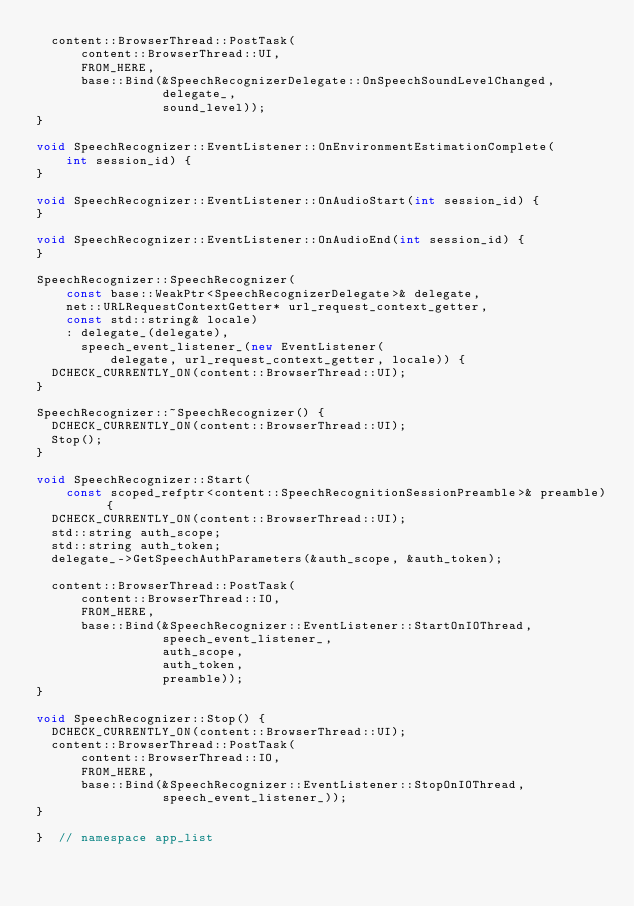Convert code to text. <code><loc_0><loc_0><loc_500><loc_500><_C++_>  content::BrowserThread::PostTask(
      content::BrowserThread::UI,
      FROM_HERE,
      base::Bind(&SpeechRecognizerDelegate::OnSpeechSoundLevelChanged,
                 delegate_,
                 sound_level));
}

void SpeechRecognizer::EventListener::OnEnvironmentEstimationComplete(
    int session_id) {
}

void SpeechRecognizer::EventListener::OnAudioStart(int session_id) {
}

void SpeechRecognizer::EventListener::OnAudioEnd(int session_id) {
}

SpeechRecognizer::SpeechRecognizer(
    const base::WeakPtr<SpeechRecognizerDelegate>& delegate,
    net::URLRequestContextGetter* url_request_context_getter,
    const std::string& locale)
    : delegate_(delegate),
      speech_event_listener_(new EventListener(
          delegate, url_request_context_getter, locale)) {
  DCHECK_CURRENTLY_ON(content::BrowserThread::UI);
}

SpeechRecognizer::~SpeechRecognizer() {
  DCHECK_CURRENTLY_ON(content::BrowserThread::UI);
  Stop();
}

void SpeechRecognizer::Start(
    const scoped_refptr<content::SpeechRecognitionSessionPreamble>& preamble) {
  DCHECK_CURRENTLY_ON(content::BrowserThread::UI);
  std::string auth_scope;
  std::string auth_token;
  delegate_->GetSpeechAuthParameters(&auth_scope, &auth_token);

  content::BrowserThread::PostTask(
      content::BrowserThread::IO,
      FROM_HERE,
      base::Bind(&SpeechRecognizer::EventListener::StartOnIOThread,
                 speech_event_listener_,
                 auth_scope,
                 auth_token,
                 preamble));
}

void SpeechRecognizer::Stop() {
  DCHECK_CURRENTLY_ON(content::BrowserThread::UI);
  content::BrowserThread::PostTask(
      content::BrowserThread::IO,
      FROM_HERE,
      base::Bind(&SpeechRecognizer::EventListener::StopOnIOThread,
                 speech_event_listener_));
}

}  // namespace app_list
</code> 